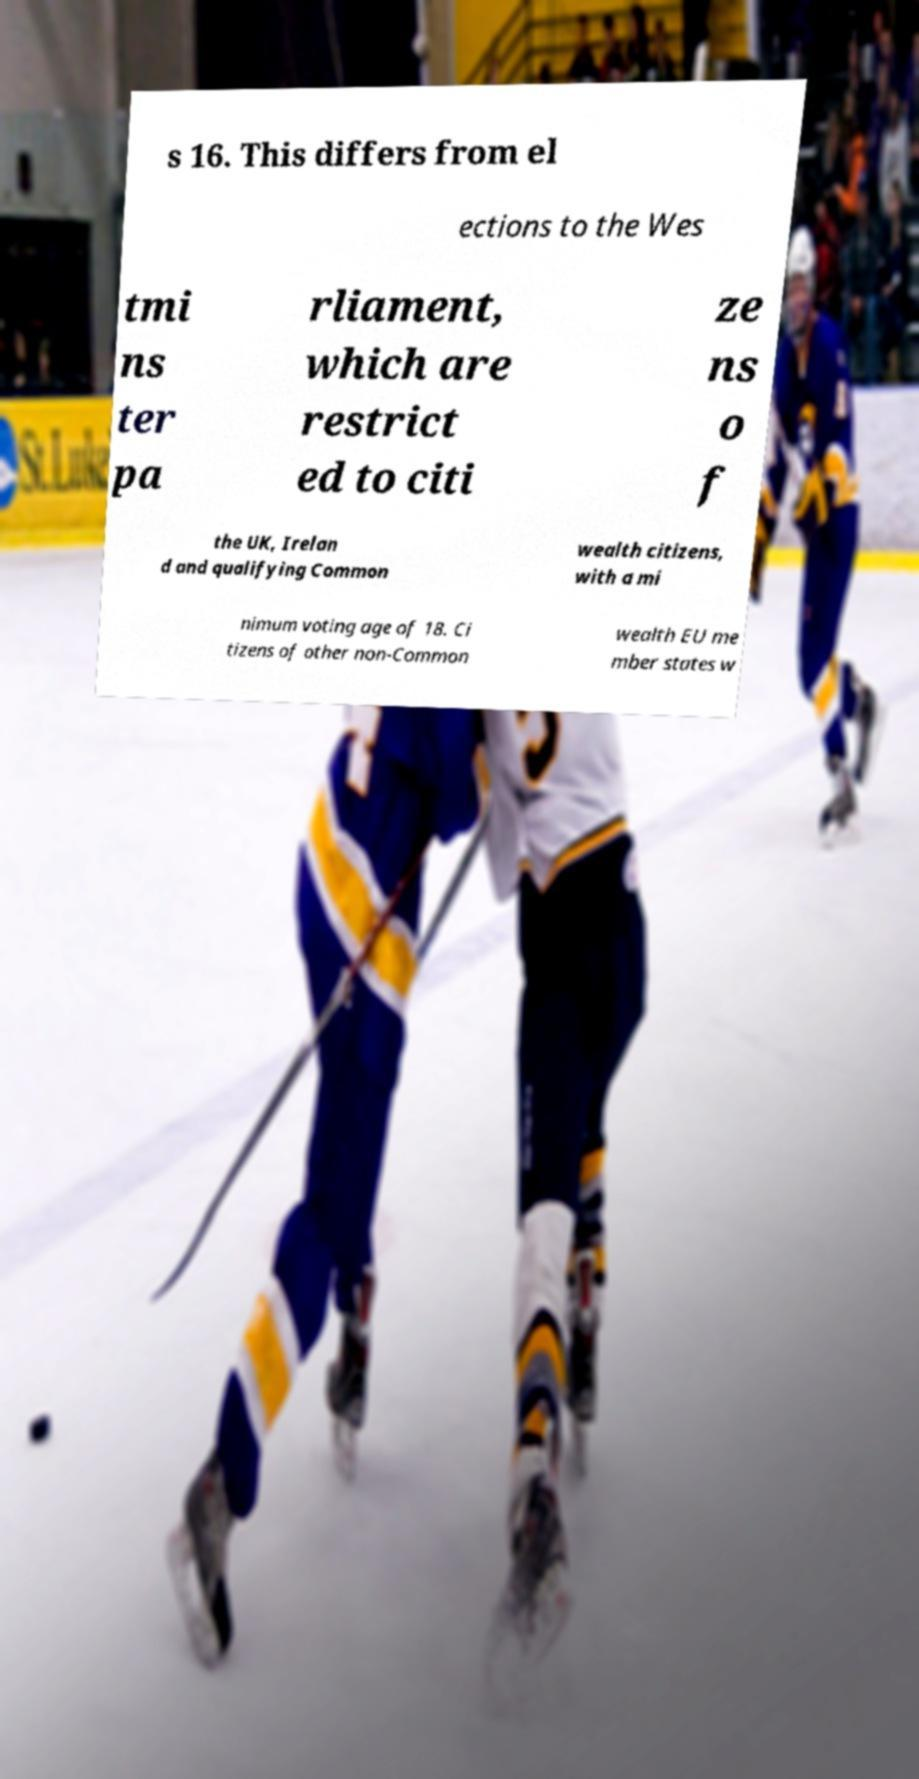Can you accurately transcribe the text from the provided image for me? s 16. This differs from el ections to the Wes tmi ns ter pa rliament, which are restrict ed to citi ze ns o f the UK, Irelan d and qualifying Common wealth citizens, with a mi nimum voting age of 18. Ci tizens of other non-Common wealth EU me mber states w 